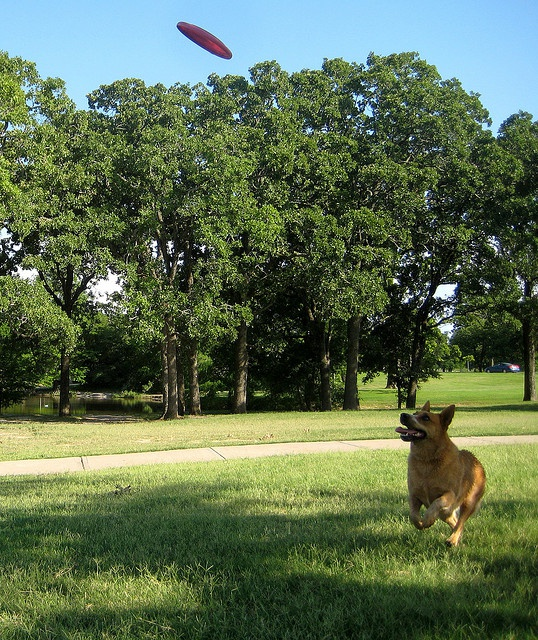Describe the objects in this image and their specific colors. I can see dog in lightblue, olive, and black tones, frisbee in lightblue, purple, and brown tones, and car in lightblue, black, navy, gray, and blue tones in this image. 